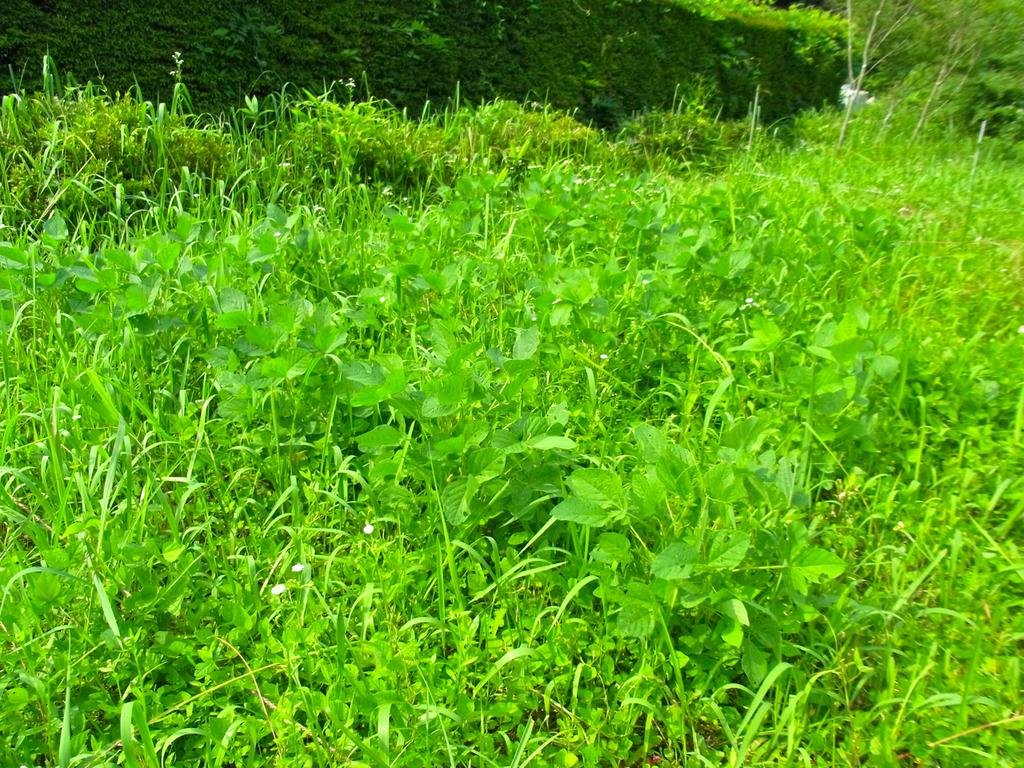What types of plants can be seen in the image? There are different varieties of plants in the image. Where are the trees located in the image? The trees are in the right corner of the image. What role does the queen play in the image? There is no queen present in the image; it features different varieties of plants and trees. Can you identify any actors in the image? There are no actors present in the image; it features different varieties of plants and trees. 